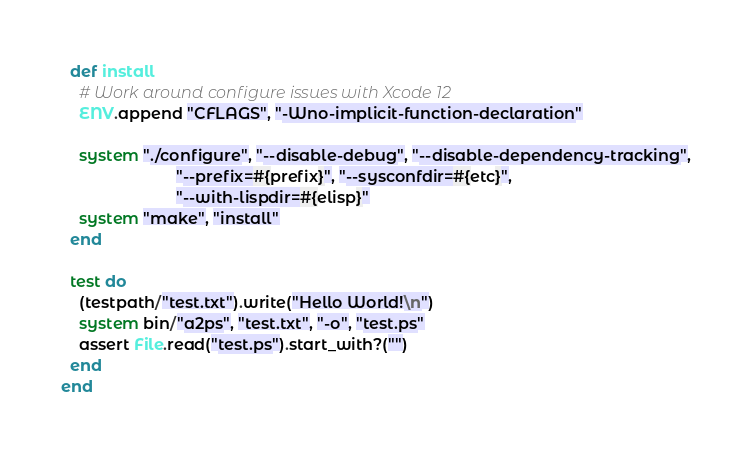Convert code to text. <code><loc_0><loc_0><loc_500><loc_500><_Ruby_>  def install
    # Work around configure issues with Xcode 12
    ENV.append "CFLAGS", "-Wno-implicit-function-declaration"

    system "./configure", "--disable-debug", "--disable-dependency-tracking",
                          "--prefix=#{prefix}", "--sysconfdir=#{etc}",
                          "--with-lispdir=#{elisp}"
    system "make", "install"
  end

  test do
    (testpath/"test.txt").write("Hello World!\n")
    system bin/"a2ps", "test.txt", "-o", "test.ps"
    assert File.read("test.ps").start_with?("")
  end
end
</code> 